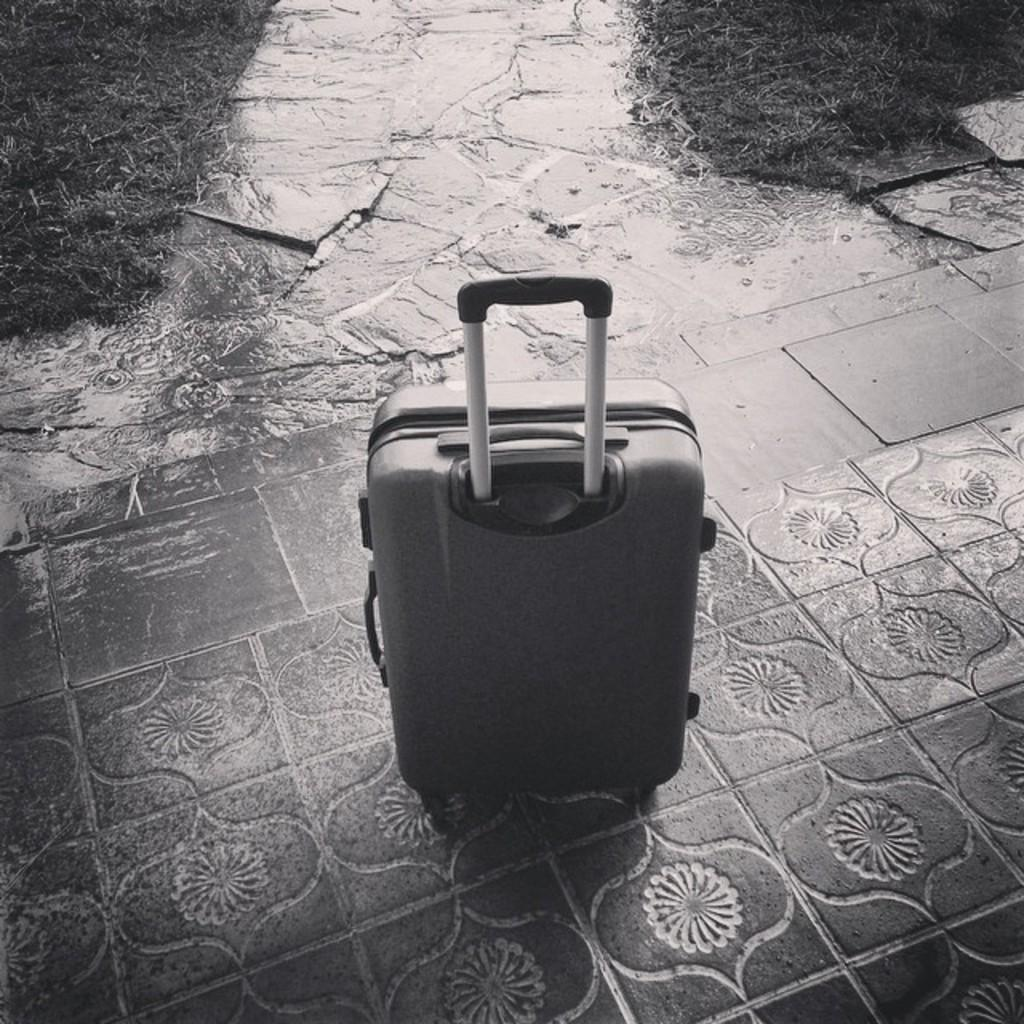What object is placed on the floor in the image? There is a luggage bag on the floor. What type of natural environment can be seen in the image? There is grass visible in the top right corner of the image. How thick is the fog in the image? There is no fog present in the image. What type of street can be seen in the image? There is no street visible in the image. 